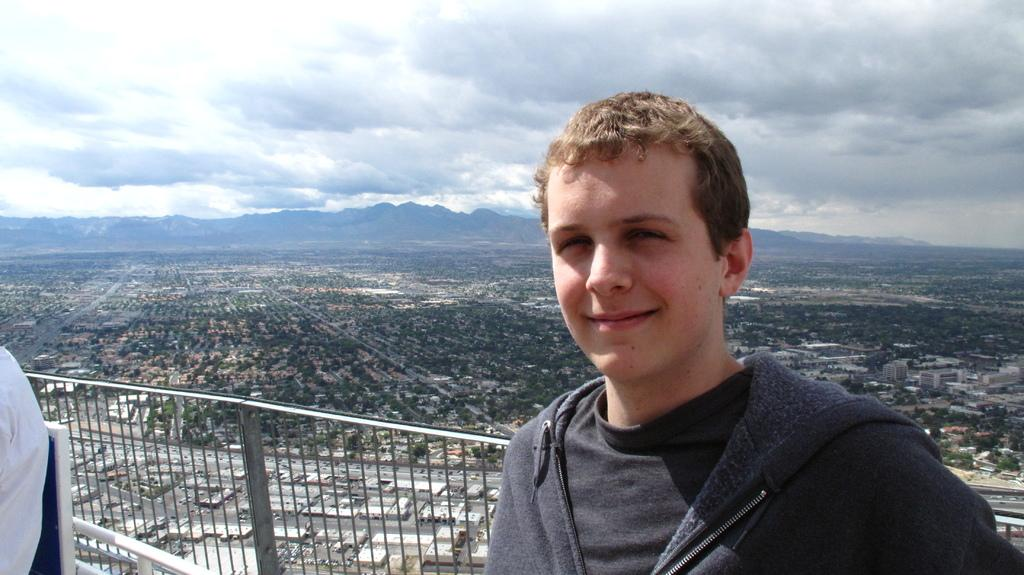What is the expression of the person in the image? The person in the image is smiling. What can be seen in the background of the image? There is a fence, trees, buildings, mountains, and the sky visible in the background of the image. Can you describe the person on the left side of the image? The person on the left side of the image is partially visible, but they appear to be smiling as well. Can you see any boats in the harbor in the image? There is no harbor present in the image. Are there any cats visible in the image? There are no cats visible in the image. 